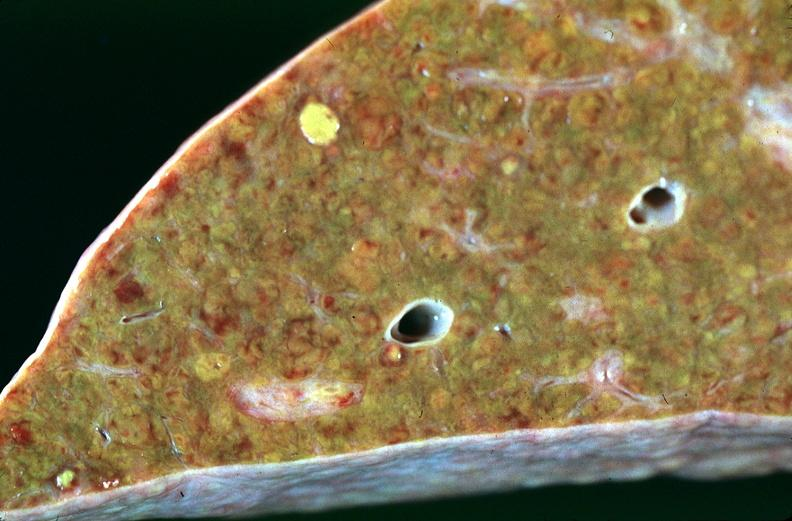does this image show liver, cirrhosis alpha-1 antitrypsin deficiency?
Answer the question using a single word or phrase. Yes 